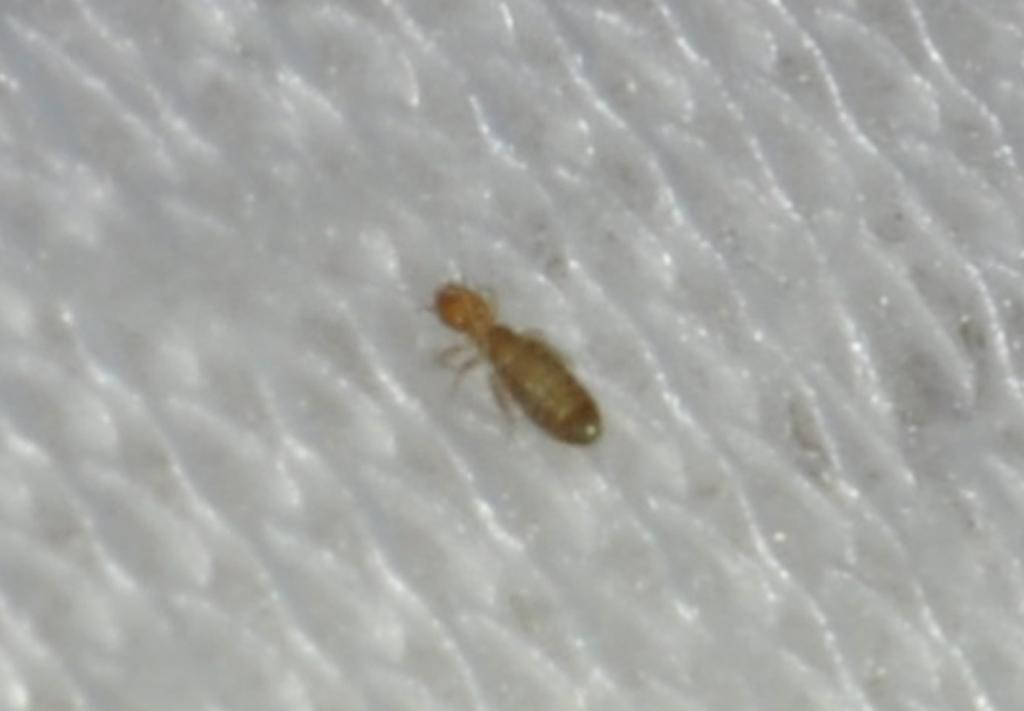What type of animal can be seen in the image? There is an insect in the image. Where is the insect located? The insect is on the ground. What type of crayon is being used to draw on the field in the image? There is no crayon or field present in the image; it only features an insect on the ground. 